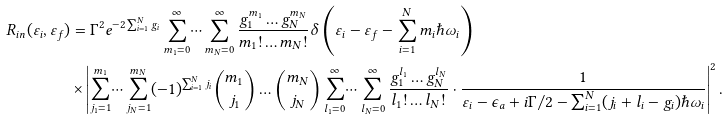Convert formula to latex. <formula><loc_0><loc_0><loc_500><loc_500>R _ { i n } ( \varepsilon _ { i } , \varepsilon _ { f } ) & = \Gamma ^ { 2 } e ^ { - 2 \sum _ { i = 1 } ^ { N } g _ { i } } \sum _ { m _ { 1 } = 0 } ^ { \infty } \dots \sum _ { m _ { N } = 0 } ^ { \infty } \frac { g _ { 1 } ^ { m _ { 1 } } \dots g _ { N } ^ { m _ { N } } } { m _ { 1 } ! \dots m _ { N } ! } \delta \left ( \varepsilon _ { i } - \varepsilon _ { f } - \sum _ { i = 1 } ^ { N } m _ { i } \hbar { \omega } _ { i } \right ) \\ & \times \left | \sum _ { j _ { 1 } = 1 } ^ { m _ { 1 } } \dots \sum _ { j _ { N } = 1 } ^ { m _ { N } } ( - 1 ) ^ { \sum _ { i = 1 } ^ { N } j _ { i } } \binom { m _ { 1 } } { j _ { 1 } } \dots \binom { m _ { N } } { j _ { N } } \sum _ { l _ { 1 } = 0 } ^ { \infty } \dots \sum _ { l _ { N } = 0 } ^ { \infty } \frac { g _ { 1 } ^ { l _ { 1 } } \dots g _ { N } ^ { l _ { N } } } { l _ { 1 } ! \dots l _ { N } ! } \cdot \frac { 1 } { \varepsilon _ { i } - \epsilon _ { a } + i \Gamma / 2 - \sum _ { i = 1 } ^ { N } ( j _ { i } + l _ { i } - g _ { i } ) \hbar { \omega } _ { i } } \right | ^ { 2 } .</formula> 